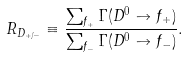Convert formula to latex. <formula><loc_0><loc_0><loc_500><loc_500>R _ { D _ { + / - } } \equiv \frac { \sum _ { f _ { + } } \Gamma ( D ^ { 0 } \to f _ { + } ) } { \sum _ { f _ { - } } \Gamma ( D ^ { 0 } \to f _ { - } ) } .</formula> 